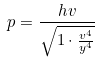<formula> <loc_0><loc_0><loc_500><loc_500>p = \frac { h v } { \sqrt { 1 \cdot \frac { v ^ { 4 } } { y ^ { 4 } } } }</formula> 